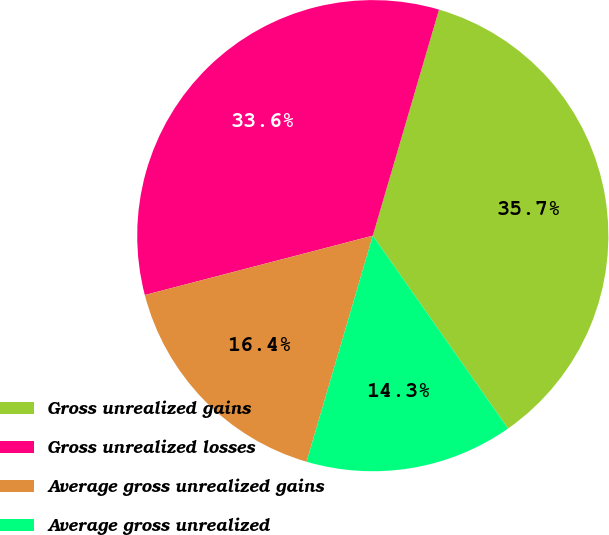<chart> <loc_0><loc_0><loc_500><loc_500><pie_chart><fcel>Gross unrealized gains<fcel>Gross unrealized losses<fcel>Average gross unrealized gains<fcel>Average gross unrealized<nl><fcel>35.73%<fcel>33.59%<fcel>16.41%<fcel>14.27%<nl></chart> 